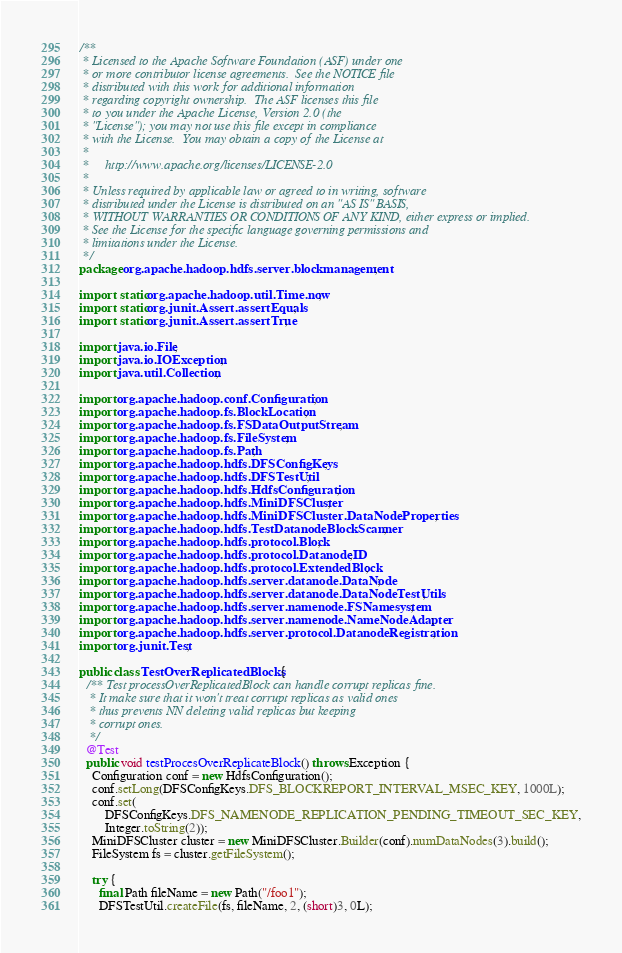Convert code to text. <code><loc_0><loc_0><loc_500><loc_500><_Java_>/**
 * Licensed to the Apache Software Foundation (ASF) under one
 * or more contributor license agreements.  See the NOTICE file
 * distributed with this work for additional information
 * regarding copyright ownership.  The ASF licenses this file
 * to you under the Apache License, Version 2.0 (the
 * "License"); you may not use this file except in compliance
 * with the License.  You may obtain a copy of the License at
 *
 *     http://www.apache.org/licenses/LICENSE-2.0
 *
 * Unless required by applicable law or agreed to in writing, software
 * distributed under the License is distributed on an "AS IS" BASIS,
 * WITHOUT WARRANTIES OR CONDITIONS OF ANY KIND, either express or implied.
 * See the License for the specific language governing permissions and
 * limitations under the License.
 */
package org.apache.hadoop.hdfs.server.blockmanagement;

import static org.apache.hadoop.util.Time.now;
import static org.junit.Assert.assertEquals;
import static org.junit.Assert.assertTrue;

import java.io.File;
import java.io.IOException;
import java.util.Collection;

import org.apache.hadoop.conf.Configuration;
import org.apache.hadoop.fs.BlockLocation;
import org.apache.hadoop.fs.FSDataOutputStream;
import org.apache.hadoop.fs.FileSystem;
import org.apache.hadoop.fs.Path;
import org.apache.hadoop.hdfs.DFSConfigKeys;
import org.apache.hadoop.hdfs.DFSTestUtil;
import org.apache.hadoop.hdfs.HdfsConfiguration;
import org.apache.hadoop.hdfs.MiniDFSCluster;
import org.apache.hadoop.hdfs.MiniDFSCluster.DataNodeProperties;
import org.apache.hadoop.hdfs.TestDatanodeBlockScanner;
import org.apache.hadoop.hdfs.protocol.Block;
import org.apache.hadoop.hdfs.protocol.DatanodeID;
import org.apache.hadoop.hdfs.protocol.ExtendedBlock;
import org.apache.hadoop.hdfs.server.datanode.DataNode;
import org.apache.hadoop.hdfs.server.datanode.DataNodeTestUtils;
import org.apache.hadoop.hdfs.server.namenode.FSNamesystem;
import org.apache.hadoop.hdfs.server.namenode.NameNodeAdapter;
import org.apache.hadoop.hdfs.server.protocol.DatanodeRegistration;
import org.junit.Test;

public class TestOverReplicatedBlocks {
  /** Test processOverReplicatedBlock can handle corrupt replicas fine.
   * It make sure that it won't treat corrupt replicas as valid ones 
   * thus prevents NN deleting valid replicas but keeping
   * corrupt ones.
   */
  @Test
  public void testProcesOverReplicateBlock() throws Exception {
    Configuration conf = new HdfsConfiguration();
    conf.setLong(DFSConfigKeys.DFS_BLOCKREPORT_INTERVAL_MSEC_KEY, 1000L);
    conf.set(
        DFSConfigKeys.DFS_NAMENODE_REPLICATION_PENDING_TIMEOUT_SEC_KEY,
        Integer.toString(2));
    MiniDFSCluster cluster = new MiniDFSCluster.Builder(conf).numDataNodes(3).build();
    FileSystem fs = cluster.getFileSystem();

    try {
      final Path fileName = new Path("/foo1");
      DFSTestUtil.createFile(fs, fileName, 2, (short)3, 0L);</code> 